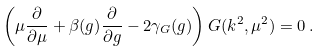<formula> <loc_0><loc_0><loc_500><loc_500>\left ( \mu \frac { \partial } { \partial \mu } + \beta ( g ) \frac { \partial } { \partial g } - 2 \gamma _ { G } ( g ) \right ) G ( k ^ { 2 } , \mu ^ { 2 } ) = 0 \, .</formula> 